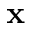<formula> <loc_0><loc_0><loc_500><loc_500>x</formula> 